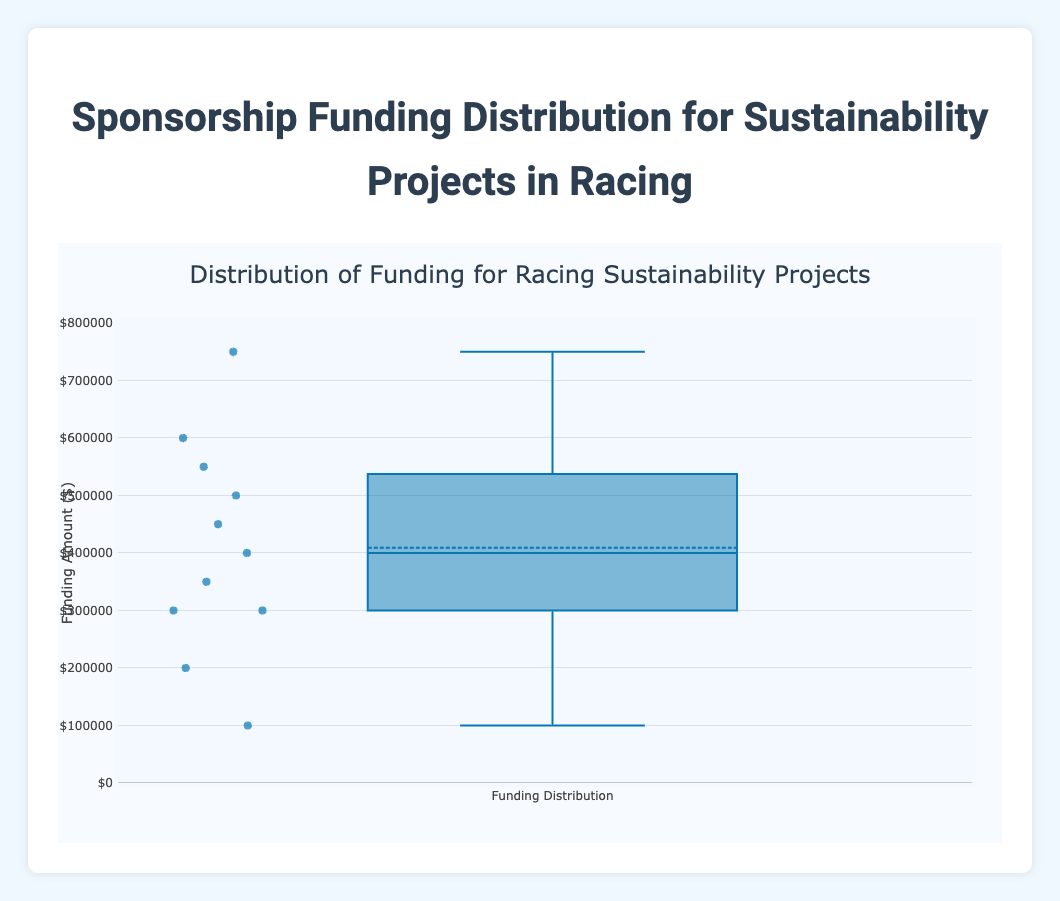What is the title of the figure? The title is displayed at the top of the figure and is typically the largest text. It reads, "Distribution of Funding for Racing Sustainability Projects".
Answer: Distribution of Funding for Racing Sustainability Projects What is the y-axis label? The y-axis label is generally found alongside the vertical axis of the plot. In this case, it is labeled "Funding Amount ($)".
Answer: Funding Amount ($) How many data points are shown in the box plot? Each point in the box plot represents a specific funding amount for a sustainability project. Counting all the points, you can see there are 11 data points.
Answer: 11 What is the median funding amount? In a box plot, the median is indicated by the line inside the box. The median funding amount is approximately $450,000.
Answer: $450,000 What is the range of the funding amounts? The range in a box plot is the difference between the maximum and minimum data points. The minimum is $100,000 and the maximum is $750,000. Therefore, the range is $750,000 - $100,000 = $650,000.
Answer: $650,000 Which funding amount is the highest? The highest funding amount is the topmost data point in the box plot's "whisker". It is $750,000.
Answer: $750,000 How many projects received more than $500,000 in funding? To determine this, count the number of data points above the $500,000 line. There are 4 data points above $500,000.
Answer: 4 What is the mean funding amount? The mean is typically represented by a marker if it is included. In this plot, the mean funding amount is approximately $440,000.
Answer: $440,000 What is the interquartile range (IQR)? The IQR can be found by subtracting the first quartile (bottom of the box) from the third quartile (top of the box). The first quartile is approximately $300,000 and the third quartile is approximately $550,000. Therefore, IQR is $550,000 - $300,000 = $250,000.
Answer: $250,000 What project funding amount is considered an outlier, if any? Outliers in a box plot are data points that fall beyond the "whiskers". Here, the $100,000 funding amount for "Eco-Friendly Fan Merchandise" is an outlier.
Answer: $100,000 